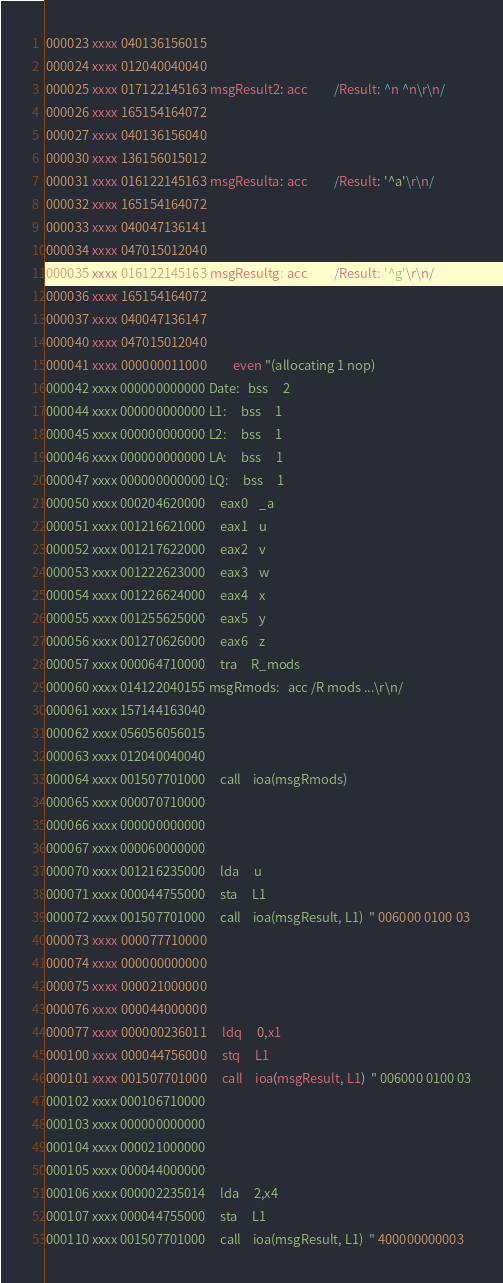Convert code to text. <code><loc_0><loc_0><loc_500><loc_500><_Octave_>000023 xxxx 040136156015 
000024 xxxx 012040040040 
000025 xxxx 017122145163 msgResult2: acc         /Result: ^n ^n\r\n/
000026 xxxx 165154164072 
000027 xxxx 040136156040 
000030 xxxx 136156015012 
000031 xxxx 016122145163 msgResulta: acc         /Result: '^a'\r\n/
000032 xxxx 165154164072 
000033 xxxx 040047136141 
000034 xxxx 047015012040 
000035 xxxx 016122145163 msgResultg: acc         /Result: '^g'\r\n/
000036 xxxx 165154164072 
000037 xxxx 040047136147 
000040 xxxx 047015012040 
000041 xxxx 000000011000         even "(allocating 1 nop)
000042 xxxx 000000000000 Date:   bss     2
000044 xxxx 000000000000 L1:     bss     1
000045 xxxx 000000000000 L2:     bss     1
000046 xxxx 000000000000 LA:     bss     1
000047 xxxx 000000000000 LQ:     bss     1
000050 xxxx 000204620000     eax0    _a
000051 xxxx 001216621000     eax1    u
000052 xxxx 001217622000     eax2    v
000053 xxxx 001222623000     eax3    w
000054 xxxx 001226624000     eax4    x
000055 xxxx 001255625000     eax5    y
000056 xxxx 001270626000     eax6    z
000057 xxxx 000064710000     tra     R_mods
000060 xxxx 014122040155 msgRmods:   acc /R mods ...\r\n/
000061 xxxx 157144163040 
000062 xxxx 056056056015 
000063 xxxx 012040040040 
000064 xxxx 001507701000     call    ioa(msgRmods)
000065 xxxx 000070710000 
000066 xxxx 000000000000 
000067 xxxx 000060000000 
000070 xxxx 001216235000     lda     u
000071 xxxx 000044755000     sta     L1
000072 xxxx 001507701000     call    ioa(msgResult, L1)  " 006000 0100 03
000073 xxxx 000077710000 
000074 xxxx 000000000000 
000075 xxxx 000021000000 
000076 xxxx 000044000000 
000077 xxxx 000000236011     ldq     0,x1
000100 xxxx 000044756000     stq     L1
000101 xxxx 001507701000     call    ioa(msgResult, L1)  " 006000 0100 03
000102 xxxx 000106710000 
000103 xxxx 000000000000 
000104 xxxx 000021000000 
000105 xxxx 000044000000 
000106 xxxx 000002235014     lda     2,x4
000107 xxxx 000044755000     sta     L1
000110 xxxx 001507701000     call    ioa(msgResult, L1)  " 400000000003</code> 